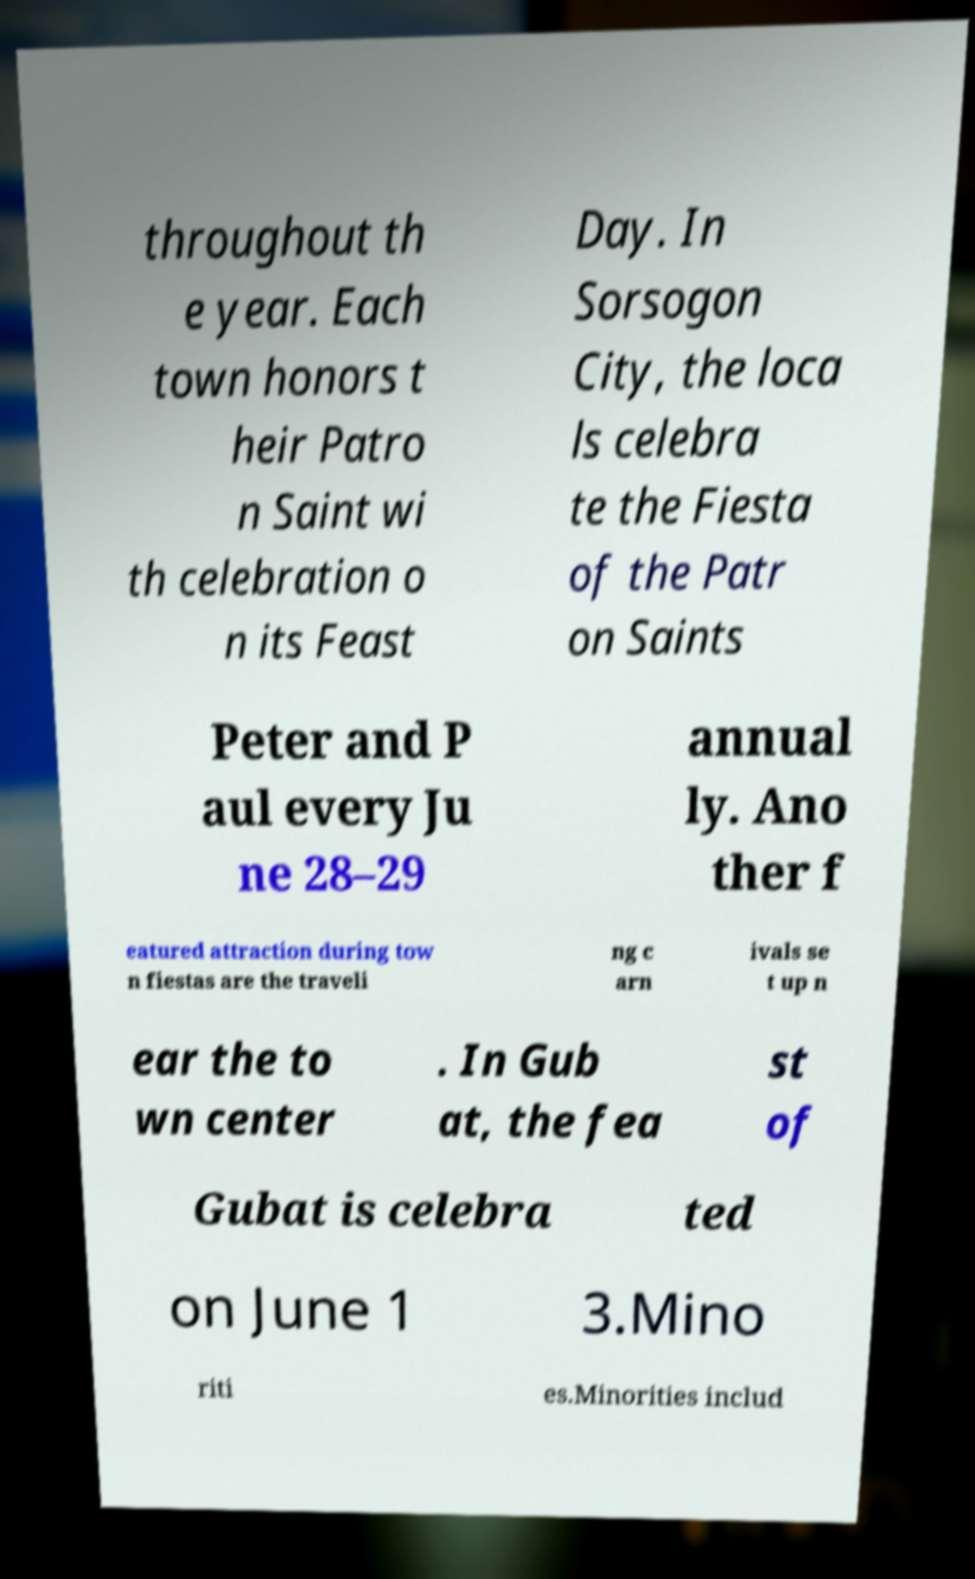There's text embedded in this image that I need extracted. Can you transcribe it verbatim? throughout th e year. Each town honors t heir Patro n Saint wi th celebration o n its Feast Day. In Sorsogon City, the loca ls celebra te the Fiesta of the Patr on Saints Peter and P aul every Ju ne 28–29 annual ly. Ano ther f eatured attraction during tow n fiestas are the traveli ng c arn ivals se t up n ear the to wn center . In Gub at, the fea st of Gubat is celebra ted on June 1 3.Mino riti es.Minorities includ 